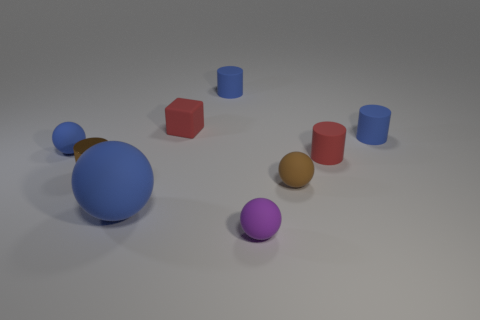What color is the matte cylinder in front of the tiny rubber sphere that is on the left side of the small ball that is in front of the brown rubber object?
Provide a short and direct response. Red. How many matte objects are either small cylinders or small purple cylinders?
Keep it short and to the point. 3. Does the metallic object have the same size as the red block?
Make the answer very short. Yes. Is the number of rubber balls that are on the left side of the tiny red rubber cube less than the number of blue things that are to the left of the small purple matte object?
Offer a very short reply. Yes. Are there any other things that have the same size as the brown metal cylinder?
Your response must be concise. Yes. How big is the rubber block?
Your answer should be very brief. Small. What number of tiny things are either purple rubber balls or blue metal spheres?
Give a very brief answer. 1. Is the size of the red rubber cube the same as the brown thing that is on the left side of the large blue object?
Provide a short and direct response. Yes. Are there any other things that have the same shape as the large rubber object?
Your response must be concise. Yes. What number of small blue cylinders are there?
Provide a succinct answer. 2. 